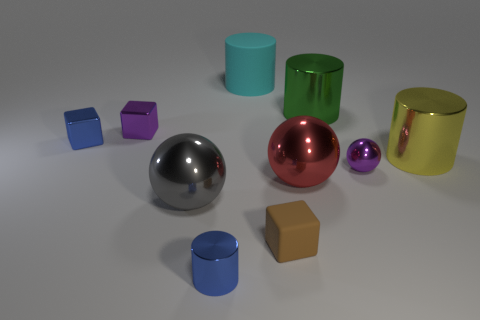What is the material of the block in front of the small purple thing to the right of the tiny brown object?
Give a very brief answer. Rubber. How many other objects are there of the same shape as the yellow thing?
Provide a succinct answer. 3. Does the purple object in front of the purple metallic block have the same shape as the tiny blue object that is right of the small purple cube?
Make the answer very short. No. Is there anything else that has the same material as the yellow thing?
Your answer should be compact. Yes. What is the blue cube made of?
Keep it short and to the point. Metal. What material is the small blue object in front of the red sphere?
Keep it short and to the point. Metal. Is there anything else that is the same color as the tiny rubber thing?
Offer a very short reply. No. There is a cyan object that is made of the same material as the brown object; what size is it?
Offer a very short reply. Large. How many large things are blue matte cubes or purple shiny balls?
Your response must be concise. 0. How big is the metallic cylinder that is behind the small blue shiny thing that is on the left side of the ball that is to the left of the tiny brown matte object?
Your answer should be compact. Large. 